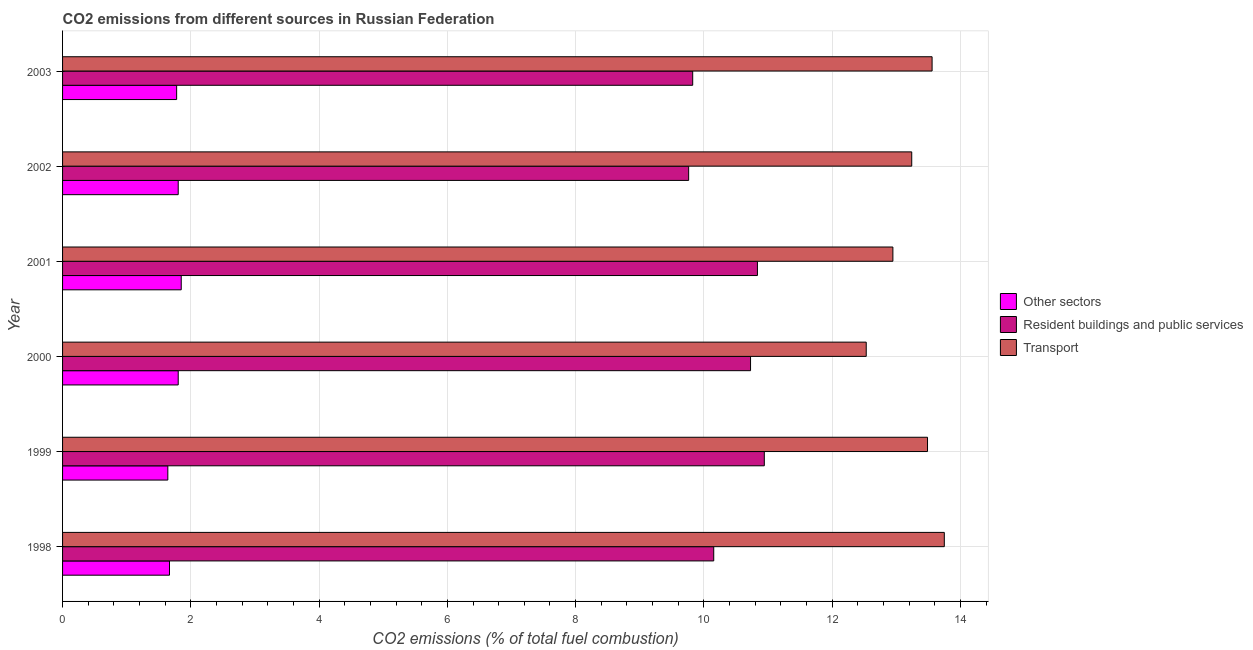How many different coloured bars are there?
Keep it short and to the point. 3. How many bars are there on the 3rd tick from the top?
Ensure brevity in your answer.  3. What is the label of the 3rd group of bars from the top?
Make the answer very short. 2001. What is the percentage of co2 emissions from resident buildings and public services in 1998?
Ensure brevity in your answer.  10.15. Across all years, what is the maximum percentage of co2 emissions from transport?
Ensure brevity in your answer.  13.75. Across all years, what is the minimum percentage of co2 emissions from transport?
Give a very brief answer. 12.53. In which year was the percentage of co2 emissions from other sectors maximum?
Keep it short and to the point. 2001. In which year was the percentage of co2 emissions from resident buildings and public services minimum?
Keep it short and to the point. 2002. What is the total percentage of co2 emissions from other sectors in the graph?
Offer a terse response. 10.54. What is the difference between the percentage of co2 emissions from other sectors in 2000 and that in 2002?
Your answer should be compact. -0. What is the difference between the percentage of co2 emissions from other sectors in 2000 and the percentage of co2 emissions from transport in 2001?
Offer a terse response. -11.14. What is the average percentage of co2 emissions from resident buildings and public services per year?
Offer a terse response. 10.37. In the year 2002, what is the difference between the percentage of co2 emissions from resident buildings and public services and percentage of co2 emissions from other sectors?
Keep it short and to the point. 7.96. What is the ratio of the percentage of co2 emissions from transport in 1998 to that in 2001?
Keep it short and to the point. 1.06. Is the difference between the percentage of co2 emissions from transport in 1998 and 2003 greater than the difference between the percentage of co2 emissions from other sectors in 1998 and 2003?
Provide a short and direct response. Yes. What is the difference between the highest and the second highest percentage of co2 emissions from resident buildings and public services?
Keep it short and to the point. 0.11. What is the difference between the highest and the lowest percentage of co2 emissions from other sectors?
Provide a succinct answer. 0.21. What does the 2nd bar from the top in 2001 represents?
Your response must be concise. Resident buildings and public services. What does the 3rd bar from the bottom in 1998 represents?
Make the answer very short. Transport. Is it the case that in every year, the sum of the percentage of co2 emissions from other sectors and percentage of co2 emissions from resident buildings and public services is greater than the percentage of co2 emissions from transport?
Provide a succinct answer. No. How many bars are there?
Provide a succinct answer. 18. How many years are there in the graph?
Provide a short and direct response. 6. What is the difference between two consecutive major ticks on the X-axis?
Keep it short and to the point. 2. Does the graph contain any zero values?
Offer a terse response. No. Does the graph contain grids?
Give a very brief answer. Yes. How many legend labels are there?
Provide a short and direct response. 3. How are the legend labels stacked?
Offer a very short reply. Vertical. What is the title of the graph?
Keep it short and to the point. CO2 emissions from different sources in Russian Federation. Does "Ages 50+" appear as one of the legend labels in the graph?
Provide a succinct answer. No. What is the label or title of the X-axis?
Your answer should be very brief. CO2 emissions (% of total fuel combustion). What is the CO2 emissions (% of total fuel combustion) in Other sectors in 1998?
Your answer should be compact. 1.67. What is the CO2 emissions (% of total fuel combustion) in Resident buildings and public services in 1998?
Your answer should be compact. 10.15. What is the CO2 emissions (% of total fuel combustion) in Transport in 1998?
Provide a succinct answer. 13.75. What is the CO2 emissions (% of total fuel combustion) in Other sectors in 1999?
Ensure brevity in your answer.  1.64. What is the CO2 emissions (% of total fuel combustion) in Resident buildings and public services in 1999?
Keep it short and to the point. 10.94. What is the CO2 emissions (% of total fuel combustion) in Transport in 1999?
Offer a very short reply. 13.49. What is the CO2 emissions (% of total fuel combustion) in Other sectors in 2000?
Give a very brief answer. 1.8. What is the CO2 emissions (% of total fuel combustion) of Resident buildings and public services in 2000?
Your answer should be very brief. 10.73. What is the CO2 emissions (% of total fuel combustion) of Transport in 2000?
Ensure brevity in your answer.  12.53. What is the CO2 emissions (% of total fuel combustion) in Other sectors in 2001?
Give a very brief answer. 1.85. What is the CO2 emissions (% of total fuel combustion) in Resident buildings and public services in 2001?
Keep it short and to the point. 10.84. What is the CO2 emissions (% of total fuel combustion) in Transport in 2001?
Keep it short and to the point. 12.95. What is the CO2 emissions (% of total fuel combustion) of Other sectors in 2002?
Your answer should be compact. 1.8. What is the CO2 emissions (% of total fuel combustion) in Resident buildings and public services in 2002?
Your answer should be compact. 9.76. What is the CO2 emissions (% of total fuel combustion) of Transport in 2002?
Make the answer very short. 13.24. What is the CO2 emissions (% of total fuel combustion) of Other sectors in 2003?
Provide a short and direct response. 1.78. What is the CO2 emissions (% of total fuel combustion) of Resident buildings and public services in 2003?
Provide a succinct answer. 9.83. What is the CO2 emissions (% of total fuel combustion) in Transport in 2003?
Your response must be concise. 13.56. Across all years, what is the maximum CO2 emissions (% of total fuel combustion) of Other sectors?
Keep it short and to the point. 1.85. Across all years, what is the maximum CO2 emissions (% of total fuel combustion) in Resident buildings and public services?
Keep it short and to the point. 10.94. Across all years, what is the maximum CO2 emissions (% of total fuel combustion) in Transport?
Provide a succinct answer. 13.75. Across all years, what is the minimum CO2 emissions (% of total fuel combustion) in Other sectors?
Provide a short and direct response. 1.64. Across all years, what is the minimum CO2 emissions (% of total fuel combustion) in Resident buildings and public services?
Ensure brevity in your answer.  9.76. Across all years, what is the minimum CO2 emissions (% of total fuel combustion) of Transport?
Give a very brief answer. 12.53. What is the total CO2 emissions (% of total fuel combustion) of Other sectors in the graph?
Your answer should be compact. 10.54. What is the total CO2 emissions (% of total fuel combustion) of Resident buildings and public services in the graph?
Make the answer very short. 62.25. What is the total CO2 emissions (% of total fuel combustion) of Transport in the graph?
Your response must be concise. 79.51. What is the difference between the CO2 emissions (% of total fuel combustion) of Other sectors in 1998 and that in 1999?
Your answer should be very brief. 0.03. What is the difference between the CO2 emissions (% of total fuel combustion) in Resident buildings and public services in 1998 and that in 1999?
Provide a succinct answer. -0.79. What is the difference between the CO2 emissions (% of total fuel combustion) of Transport in 1998 and that in 1999?
Provide a short and direct response. 0.26. What is the difference between the CO2 emissions (% of total fuel combustion) of Other sectors in 1998 and that in 2000?
Give a very brief answer. -0.14. What is the difference between the CO2 emissions (% of total fuel combustion) of Resident buildings and public services in 1998 and that in 2000?
Provide a succinct answer. -0.57. What is the difference between the CO2 emissions (% of total fuel combustion) of Transport in 1998 and that in 2000?
Your answer should be very brief. 1.22. What is the difference between the CO2 emissions (% of total fuel combustion) in Other sectors in 1998 and that in 2001?
Your response must be concise. -0.18. What is the difference between the CO2 emissions (% of total fuel combustion) in Resident buildings and public services in 1998 and that in 2001?
Provide a succinct answer. -0.68. What is the difference between the CO2 emissions (% of total fuel combustion) in Transport in 1998 and that in 2001?
Provide a short and direct response. 0.8. What is the difference between the CO2 emissions (% of total fuel combustion) of Other sectors in 1998 and that in 2002?
Keep it short and to the point. -0.14. What is the difference between the CO2 emissions (% of total fuel combustion) of Resident buildings and public services in 1998 and that in 2002?
Keep it short and to the point. 0.39. What is the difference between the CO2 emissions (% of total fuel combustion) of Transport in 1998 and that in 2002?
Ensure brevity in your answer.  0.51. What is the difference between the CO2 emissions (% of total fuel combustion) in Other sectors in 1998 and that in 2003?
Give a very brief answer. -0.11. What is the difference between the CO2 emissions (% of total fuel combustion) of Resident buildings and public services in 1998 and that in 2003?
Offer a terse response. 0.33. What is the difference between the CO2 emissions (% of total fuel combustion) in Transport in 1998 and that in 2003?
Provide a succinct answer. 0.19. What is the difference between the CO2 emissions (% of total fuel combustion) of Other sectors in 1999 and that in 2000?
Keep it short and to the point. -0.16. What is the difference between the CO2 emissions (% of total fuel combustion) of Resident buildings and public services in 1999 and that in 2000?
Keep it short and to the point. 0.21. What is the difference between the CO2 emissions (% of total fuel combustion) of Transport in 1999 and that in 2000?
Provide a succinct answer. 0.96. What is the difference between the CO2 emissions (% of total fuel combustion) of Other sectors in 1999 and that in 2001?
Provide a succinct answer. -0.21. What is the difference between the CO2 emissions (% of total fuel combustion) of Resident buildings and public services in 1999 and that in 2001?
Make the answer very short. 0.11. What is the difference between the CO2 emissions (% of total fuel combustion) in Transport in 1999 and that in 2001?
Provide a short and direct response. 0.54. What is the difference between the CO2 emissions (% of total fuel combustion) of Other sectors in 1999 and that in 2002?
Give a very brief answer. -0.16. What is the difference between the CO2 emissions (% of total fuel combustion) in Resident buildings and public services in 1999 and that in 2002?
Your response must be concise. 1.18. What is the difference between the CO2 emissions (% of total fuel combustion) of Transport in 1999 and that in 2002?
Your answer should be compact. 0.25. What is the difference between the CO2 emissions (% of total fuel combustion) of Other sectors in 1999 and that in 2003?
Your answer should be very brief. -0.14. What is the difference between the CO2 emissions (% of total fuel combustion) of Resident buildings and public services in 1999 and that in 2003?
Ensure brevity in your answer.  1.12. What is the difference between the CO2 emissions (% of total fuel combustion) in Transport in 1999 and that in 2003?
Provide a short and direct response. -0.07. What is the difference between the CO2 emissions (% of total fuel combustion) of Other sectors in 2000 and that in 2001?
Give a very brief answer. -0.05. What is the difference between the CO2 emissions (% of total fuel combustion) in Resident buildings and public services in 2000 and that in 2001?
Keep it short and to the point. -0.11. What is the difference between the CO2 emissions (% of total fuel combustion) in Transport in 2000 and that in 2001?
Provide a succinct answer. -0.42. What is the difference between the CO2 emissions (% of total fuel combustion) in Other sectors in 2000 and that in 2002?
Offer a terse response. -0. What is the difference between the CO2 emissions (% of total fuel combustion) in Resident buildings and public services in 2000 and that in 2002?
Provide a succinct answer. 0.96. What is the difference between the CO2 emissions (% of total fuel combustion) in Transport in 2000 and that in 2002?
Your response must be concise. -0.71. What is the difference between the CO2 emissions (% of total fuel combustion) of Other sectors in 2000 and that in 2003?
Give a very brief answer. 0.02. What is the difference between the CO2 emissions (% of total fuel combustion) of Resident buildings and public services in 2000 and that in 2003?
Offer a terse response. 0.9. What is the difference between the CO2 emissions (% of total fuel combustion) in Transport in 2000 and that in 2003?
Offer a very short reply. -1.03. What is the difference between the CO2 emissions (% of total fuel combustion) in Other sectors in 2001 and that in 2002?
Give a very brief answer. 0.05. What is the difference between the CO2 emissions (% of total fuel combustion) of Resident buildings and public services in 2001 and that in 2002?
Give a very brief answer. 1.07. What is the difference between the CO2 emissions (% of total fuel combustion) of Transport in 2001 and that in 2002?
Keep it short and to the point. -0.29. What is the difference between the CO2 emissions (% of total fuel combustion) in Other sectors in 2001 and that in 2003?
Provide a short and direct response. 0.07. What is the difference between the CO2 emissions (% of total fuel combustion) in Resident buildings and public services in 2001 and that in 2003?
Make the answer very short. 1.01. What is the difference between the CO2 emissions (% of total fuel combustion) of Transport in 2001 and that in 2003?
Keep it short and to the point. -0.61. What is the difference between the CO2 emissions (% of total fuel combustion) of Other sectors in 2002 and that in 2003?
Provide a succinct answer. 0.02. What is the difference between the CO2 emissions (% of total fuel combustion) of Resident buildings and public services in 2002 and that in 2003?
Ensure brevity in your answer.  -0.06. What is the difference between the CO2 emissions (% of total fuel combustion) of Transport in 2002 and that in 2003?
Provide a succinct answer. -0.32. What is the difference between the CO2 emissions (% of total fuel combustion) in Other sectors in 1998 and the CO2 emissions (% of total fuel combustion) in Resident buildings and public services in 1999?
Provide a short and direct response. -9.27. What is the difference between the CO2 emissions (% of total fuel combustion) of Other sectors in 1998 and the CO2 emissions (% of total fuel combustion) of Transport in 1999?
Your response must be concise. -11.82. What is the difference between the CO2 emissions (% of total fuel combustion) in Resident buildings and public services in 1998 and the CO2 emissions (% of total fuel combustion) in Transport in 1999?
Your answer should be very brief. -3.33. What is the difference between the CO2 emissions (% of total fuel combustion) of Other sectors in 1998 and the CO2 emissions (% of total fuel combustion) of Resident buildings and public services in 2000?
Provide a short and direct response. -9.06. What is the difference between the CO2 emissions (% of total fuel combustion) of Other sectors in 1998 and the CO2 emissions (% of total fuel combustion) of Transport in 2000?
Your response must be concise. -10.86. What is the difference between the CO2 emissions (% of total fuel combustion) in Resident buildings and public services in 1998 and the CO2 emissions (% of total fuel combustion) in Transport in 2000?
Keep it short and to the point. -2.38. What is the difference between the CO2 emissions (% of total fuel combustion) in Other sectors in 1998 and the CO2 emissions (% of total fuel combustion) in Resident buildings and public services in 2001?
Your answer should be very brief. -9.17. What is the difference between the CO2 emissions (% of total fuel combustion) in Other sectors in 1998 and the CO2 emissions (% of total fuel combustion) in Transport in 2001?
Offer a very short reply. -11.28. What is the difference between the CO2 emissions (% of total fuel combustion) of Resident buildings and public services in 1998 and the CO2 emissions (% of total fuel combustion) of Transport in 2001?
Offer a very short reply. -2.79. What is the difference between the CO2 emissions (% of total fuel combustion) in Other sectors in 1998 and the CO2 emissions (% of total fuel combustion) in Resident buildings and public services in 2002?
Provide a short and direct response. -8.1. What is the difference between the CO2 emissions (% of total fuel combustion) in Other sectors in 1998 and the CO2 emissions (% of total fuel combustion) in Transport in 2002?
Provide a succinct answer. -11.57. What is the difference between the CO2 emissions (% of total fuel combustion) of Resident buildings and public services in 1998 and the CO2 emissions (% of total fuel combustion) of Transport in 2002?
Provide a short and direct response. -3.09. What is the difference between the CO2 emissions (% of total fuel combustion) in Other sectors in 1998 and the CO2 emissions (% of total fuel combustion) in Resident buildings and public services in 2003?
Give a very brief answer. -8.16. What is the difference between the CO2 emissions (% of total fuel combustion) of Other sectors in 1998 and the CO2 emissions (% of total fuel combustion) of Transport in 2003?
Give a very brief answer. -11.89. What is the difference between the CO2 emissions (% of total fuel combustion) in Resident buildings and public services in 1998 and the CO2 emissions (% of total fuel combustion) in Transport in 2003?
Make the answer very short. -3.4. What is the difference between the CO2 emissions (% of total fuel combustion) in Other sectors in 1999 and the CO2 emissions (% of total fuel combustion) in Resident buildings and public services in 2000?
Offer a terse response. -9.09. What is the difference between the CO2 emissions (% of total fuel combustion) in Other sectors in 1999 and the CO2 emissions (% of total fuel combustion) in Transport in 2000?
Your answer should be compact. -10.89. What is the difference between the CO2 emissions (% of total fuel combustion) in Resident buildings and public services in 1999 and the CO2 emissions (% of total fuel combustion) in Transport in 2000?
Your answer should be very brief. -1.59. What is the difference between the CO2 emissions (% of total fuel combustion) of Other sectors in 1999 and the CO2 emissions (% of total fuel combustion) of Resident buildings and public services in 2001?
Your response must be concise. -9.19. What is the difference between the CO2 emissions (% of total fuel combustion) of Other sectors in 1999 and the CO2 emissions (% of total fuel combustion) of Transport in 2001?
Provide a succinct answer. -11.31. What is the difference between the CO2 emissions (% of total fuel combustion) in Resident buildings and public services in 1999 and the CO2 emissions (% of total fuel combustion) in Transport in 2001?
Offer a very short reply. -2. What is the difference between the CO2 emissions (% of total fuel combustion) of Other sectors in 1999 and the CO2 emissions (% of total fuel combustion) of Resident buildings and public services in 2002?
Give a very brief answer. -8.12. What is the difference between the CO2 emissions (% of total fuel combustion) of Other sectors in 1999 and the CO2 emissions (% of total fuel combustion) of Transport in 2002?
Offer a very short reply. -11.6. What is the difference between the CO2 emissions (% of total fuel combustion) in Resident buildings and public services in 1999 and the CO2 emissions (% of total fuel combustion) in Transport in 2002?
Ensure brevity in your answer.  -2.3. What is the difference between the CO2 emissions (% of total fuel combustion) in Other sectors in 1999 and the CO2 emissions (% of total fuel combustion) in Resident buildings and public services in 2003?
Keep it short and to the point. -8.18. What is the difference between the CO2 emissions (% of total fuel combustion) of Other sectors in 1999 and the CO2 emissions (% of total fuel combustion) of Transport in 2003?
Ensure brevity in your answer.  -11.92. What is the difference between the CO2 emissions (% of total fuel combustion) in Resident buildings and public services in 1999 and the CO2 emissions (% of total fuel combustion) in Transport in 2003?
Make the answer very short. -2.62. What is the difference between the CO2 emissions (% of total fuel combustion) in Other sectors in 2000 and the CO2 emissions (% of total fuel combustion) in Resident buildings and public services in 2001?
Give a very brief answer. -9.03. What is the difference between the CO2 emissions (% of total fuel combustion) of Other sectors in 2000 and the CO2 emissions (% of total fuel combustion) of Transport in 2001?
Provide a succinct answer. -11.14. What is the difference between the CO2 emissions (% of total fuel combustion) of Resident buildings and public services in 2000 and the CO2 emissions (% of total fuel combustion) of Transport in 2001?
Offer a very short reply. -2.22. What is the difference between the CO2 emissions (% of total fuel combustion) of Other sectors in 2000 and the CO2 emissions (% of total fuel combustion) of Resident buildings and public services in 2002?
Offer a very short reply. -7.96. What is the difference between the CO2 emissions (% of total fuel combustion) in Other sectors in 2000 and the CO2 emissions (% of total fuel combustion) in Transport in 2002?
Ensure brevity in your answer.  -11.44. What is the difference between the CO2 emissions (% of total fuel combustion) of Resident buildings and public services in 2000 and the CO2 emissions (% of total fuel combustion) of Transport in 2002?
Give a very brief answer. -2.51. What is the difference between the CO2 emissions (% of total fuel combustion) of Other sectors in 2000 and the CO2 emissions (% of total fuel combustion) of Resident buildings and public services in 2003?
Your response must be concise. -8.02. What is the difference between the CO2 emissions (% of total fuel combustion) in Other sectors in 2000 and the CO2 emissions (% of total fuel combustion) in Transport in 2003?
Your answer should be very brief. -11.76. What is the difference between the CO2 emissions (% of total fuel combustion) of Resident buildings and public services in 2000 and the CO2 emissions (% of total fuel combustion) of Transport in 2003?
Your answer should be compact. -2.83. What is the difference between the CO2 emissions (% of total fuel combustion) of Other sectors in 2001 and the CO2 emissions (% of total fuel combustion) of Resident buildings and public services in 2002?
Your answer should be compact. -7.91. What is the difference between the CO2 emissions (% of total fuel combustion) of Other sectors in 2001 and the CO2 emissions (% of total fuel combustion) of Transport in 2002?
Your response must be concise. -11.39. What is the difference between the CO2 emissions (% of total fuel combustion) of Resident buildings and public services in 2001 and the CO2 emissions (% of total fuel combustion) of Transport in 2002?
Your response must be concise. -2.41. What is the difference between the CO2 emissions (% of total fuel combustion) in Other sectors in 2001 and the CO2 emissions (% of total fuel combustion) in Resident buildings and public services in 2003?
Your answer should be very brief. -7.98. What is the difference between the CO2 emissions (% of total fuel combustion) of Other sectors in 2001 and the CO2 emissions (% of total fuel combustion) of Transport in 2003?
Provide a succinct answer. -11.71. What is the difference between the CO2 emissions (% of total fuel combustion) of Resident buildings and public services in 2001 and the CO2 emissions (% of total fuel combustion) of Transport in 2003?
Your response must be concise. -2.72. What is the difference between the CO2 emissions (% of total fuel combustion) of Other sectors in 2002 and the CO2 emissions (% of total fuel combustion) of Resident buildings and public services in 2003?
Make the answer very short. -8.02. What is the difference between the CO2 emissions (% of total fuel combustion) of Other sectors in 2002 and the CO2 emissions (% of total fuel combustion) of Transport in 2003?
Give a very brief answer. -11.76. What is the difference between the CO2 emissions (% of total fuel combustion) in Resident buildings and public services in 2002 and the CO2 emissions (% of total fuel combustion) in Transport in 2003?
Your response must be concise. -3.8. What is the average CO2 emissions (% of total fuel combustion) of Other sectors per year?
Make the answer very short. 1.76. What is the average CO2 emissions (% of total fuel combustion) in Resident buildings and public services per year?
Give a very brief answer. 10.37. What is the average CO2 emissions (% of total fuel combustion) in Transport per year?
Offer a terse response. 13.25. In the year 1998, what is the difference between the CO2 emissions (% of total fuel combustion) in Other sectors and CO2 emissions (% of total fuel combustion) in Resident buildings and public services?
Provide a short and direct response. -8.49. In the year 1998, what is the difference between the CO2 emissions (% of total fuel combustion) of Other sectors and CO2 emissions (% of total fuel combustion) of Transport?
Give a very brief answer. -12.08. In the year 1998, what is the difference between the CO2 emissions (% of total fuel combustion) in Resident buildings and public services and CO2 emissions (% of total fuel combustion) in Transport?
Give a very brief answer. -3.6. In the year 1999, what is the difference between the CO2 emissions (% of total fuel combustion) of Other sectors and CO2 emissions (% of total fuel combustion) of Resident buildings and public services?
Offer a terse response. -9.3. In the year 1999, what is the difference between the CO2 emissions (% of total fuel combustion) of Other sectors and CO2 emissions (% of total fuel combustion) of Transport?
Offer a very short reply. -11.85. In the year 1999, what is the difference between the CO2 emissions (% of total fuel combustion) in Resident buildings and public services and CO2 emissions (% of total fuel combustion) in Transport?
Provide a short and direct response. -2.54. In the year 2000, what is the difference between the CO2 emissions (% of total fuel combustion) in Other sectors and CO2 emissions (% of total fuel combustion) in Resident buildings and public services?
Ensure brevity in your answer.  -8.92. In the year 2000, what is the difference between the CO2 emissions (% of total fuel combustion) in Other sectors and CO2 emissions (% of total fuel combustion) in Transport?
Make the answer very short. -10.73. In the year 2000, what is the difference between the CO2 emissions (% of total fuel combustion) in Resident buildings and public services and CO2 emissions (% of total fuel combustion) in Transport?
Offer a terse response. -1.8. In the year 2001, what is the difference between the CO2 emissions (% of total fuel combustion) of Other sectors and CO2 emissions (% of total fuel combustion) of Resident buildings and public services?
Offer a very short reply. -8.98. In the year 2001, what is the difference between the CO2 emissions (% of total fuel combustion) in Other sectors and CO2 emissions (% of total fuel combustion) in Transport?
Keep it short and to the point. -11.1. In the year 2001, what is the difference between the CO2 emissions (% of total fuel combustion) in Resident buildings and public services and CO2 emissions (% of total fuel combustion) in Transport?
Ensure brevity in your answer.  -2.11. In the year 2002, what is the difference between the CO2 emissions (% of total fuel combustion) of Other sectors and CO2 emissions (% of total fuel combustion) of Resident buildings and public services?
Provide a short and direct response. -7.96. In the year 2002, what is the difference between the CO2 emissions (% of total fuel combustion) of Other sectors and CO2 emissions (% of total fuel combustion) of Transport?
Your answer should be compact. -11.44. In the year 2002, what is the difference between the CO2 emissions (% of total fuel combustion) of Resident buildings and public services and CO2 emissions (% of total fuel combustion) of Transport?
Keep it short and to the point. -3.48. In the year 2003, what is the difference between the CO2 emissions (% of total fuel combustion) of Other sectors and CO2 emissions (% of total fuel combustion) of Resident buildings and public services?
Your answer should be compact. -8.05. In the year 2003, what is the difference between the CO2 emissions (% of total fuel combustion) in Other sectors and CO2 emissions (% of total fuel combustion) in Transport?
Your answer should be very brief. -11.78. In the year 2003, what is the difference between the CO2 emissions (% of total fuel combustion) in Resident buildings and public services and CO2 emissions (% of total fuel combustion) in Transport?
Offer a very short reply. -3.73. What is the ratio of the CO2 emissions (% of total fuel combustion) in Other sectors in 1998 to that in 1999?
Offer a terse response. 1.02. What is the ratio of the CO2 emissions (% of total fuel combustion) of Resident buildings and public services in 1998 to that in 1999?
Keep it short and to the point. 0.93. What is the ratio of the CO2 emissions (% of total fuel combustion) of Transport in 1998 to that in 1999?
Provide a succinct answer. 1.02. What is the ratio of the CO2 emissions (% of total fuel combustion) of Other sectors in 1998 to that in 2000?
Ensure brevity in your answer.  0.92. What is the ratio of the CO2 emissions (% of total fuel combustion) in Resident buildings and public services in 1998 to that in 2000?
Provide a short and direct response. 0.95. What is the ratio of the CO2 emissions (% of total fuel combustion) in Transport in 1998 to that in 2000?
Your answer should be very brief. 1.1. What is the ratio of the CO2 emissions (% of total fuel combustion) of Other sectors in 1998 to that in 2001?
Your answer should be compact. 0.9. What is the ratio of the CO2 emissions (% of total fuel combustion) of Resident buildings and public services in 1998 to that in 2001?
Offer a very short reply. 0.94. What is the ratio of the CO2 emissions (% of total fuel combustion) of Transport in 1998 to that in 2001?
Provide a succinct answer. 1.06. What is the ratio of the CO2 emissions (% of total fuel combustion) of Other sectors in 1998 to that in 2002?
Offer a terse response. 0.92. What is the ratio of the CO2 emissions (% of total fuel combustion) in Resident buildings and public services in 1998 to that in 2002?
Keep it short and to the point. 1.04. What is the ratio of the CO2 emissions (% of total fuel combustion) of Transport in 1998 to that in 2002?
Keep it short and to the point. 1.04. What is the ratio of the CO2 emissions (% of total fuel combustion) in Other sectors in 1998 to that in 2003?
Provide a short and direct response. 0.94. What is the ratio of the CO2 emissions (% of total fuel combustion) in Resident buildings and public services in 1998 to that in 2003?
Make the answer very short. 1.03. What is the ratio of the CO2 emissions (% of total fuel combustion) in Transport in 1998 to that in 2003?
Your answer should be compact. 1.01. What is the ratio of the CO2 emissions (% of total fuel combustion) of Other sectors in 1999 to that in 2000?
Give a very brief answer. 0.91. What is the ratio of the CO2 emissions (% of total fuel combustion) of Resident buildings and public services in 1999 to that in 2000?
Offer a very short reply. 1.02. What is the ratio of the CO2 emissions (% of total fuel combustion) in Transport in 1999 to that in 2000?
Ensure brevity in your answer.  1.08. What is the ratio of the CO2 emissions (% of total fuel combustion) in Other sectors in 1999 to that in 2001?
Offer a terse response. 0.89. What is the ratio of the CO2 emissions (% of total fuel combustion) of Resident buildings and public services in 1999 to that in 2001?
Ensure brevity in your answer.  1.01. What is the ratio of the CO2 emissions (% of total fuel combustion) in Transport in 1999 to that in 2001?
Your response must be concise. 1.04. What is the ratio of the CO2 emissions (% of total fuel combustion) in Other sectors in 1999 to that in 2002?
Your response must be concise. 0.91. What is the ratio of the CO2 emissions (% of total fuel combustion) in Resident buildings and public services in 1999 to that in 2002?
Ensure brevity in your answer.  1.12. What is the ratio of the CO2 emissions (% of total fuel combustion) of Transport in 1999 to that in 2002?
Your answer should be compact. 1.02. What is the ratio of the CO2 emissions (% of total fuel combustion) in Other sectors in 1999 to that in 2003?
Your answer should be compact. 0.92. What is the ratio of the CO2 emissions (% of total fuel combustion) of Resident buildings and public services in 1999 to that in 2003?
Give a very brief answer. 1.11. What is the ratio of the CO2 emissions (% of total fuel combustion) in Transport in 1999 to that in 2003?
Keep it short and to the point. 0.99. What is the ratio of the CO2 emissions (% of total fuel combustion) in Other sectors in 2000 to that in 2001?
Make the answer very short. 0.97. What is the ratio of the CO2 emissions (% of total fuel combustion) of Resident buildings and public services in 2000 to that in 2001?
Offer a terse response. 0.99. What is the ratio of the CO2 emissions (% of total fuel combustion) in Transport in 2000 to that in 2001?
Make the answer very short. 0.97. What is the ratio of the CO2 emissions (% of total fuel combustion) in Other sectors in 2000 to that in 2002?
Your answer should be very brief. 1. What is the ratio of the CO2 emissions (% of total fuel combustion) in Resident buildings and public services in 2000 to that in 2002?
Your response must be concise. 1.1. What is the ratio of the CO2 emissions (% of total fuel combustion) in Transport in 2000 to that in 2002?
Ensure brevity in your answer.  0.95. What is the ratio of the CO2 emissions (% of total fuel combustion) of Other sectors in 2000 to that in 2003?
Your answer should be compact. 1.01. What is the ratio of the CO2 emissions (% of total fuel combustion) in Resident buildings and public services in 2000 to that in 2003?
Your answer should be very brief. 1.09. What is the ratio of the CO2 emissions (% of total fuel combustion) of Transport in 2000 to that in 2003?
Provide a short and direct response. 0.92. What is the ratio of the CO2 emissions (% of total fuel combustion) in Other sectors in 2001 to that in 2002?
Provide a succinct answer. 1.03. What is the ratio of the CO2 emissions (% of total fuel combustion) in Resident buildings and public services in 2001 to that in 2002?
Your answer should be compact. 1.11. What is the ratio of the CO2 emissions (% of total fuel combustion) in Transport in 2001 to that in 2002?
Provide a succinct answer. 0.98. What is the ratio of the CO2 emissions (% of total fuel combustion) in Other sectors in 2001 to that in 2003?
Make the answer very short. 1.04. What is the ratio of the CO2 emissions (% of total fuel combustion) in Resident buildings and public services in 2001 to that in 2003?
Offer a very short reply. 1.1. What is the ratio of the CO2 emissions (% of total fuel combustion) of Transport in 2001 to that in 2003?
Make the answer very short. 0.95. What is the ratio of the CO2 emissions (% of total fuel combustion) of Other sectors in 2002 to that in 2003?
Give a very brief answer. 1.01. What is the ratio of the CO2 emissions (% of total fuel combustion) in Transport in 2002 to that in 2003?
Your response must be concise. 0.98. What is the difference between the highest and the second highest CO2 emissions (% of total fuel combustion) in Other sectors?
Ensure brevity in your answer.  0.05. What is the difference between the highest and the second highest CO2 emissions (% of total fuel combustion) of Resident buildings and public services?
Your response must be concise. 0.11. What is the difference between the highest and the second highest CO2 emissions (% of total fuel combustion) in Transport?
Provide a succinct answer. 0.19. What is the difference between the highest and the lowest CO2 emissions (% of total fuel combustion) of Other sectors?
Offer a very short reply. 0.21. What is the difference between the highest and the lowest CO2 emissions (% of total fuel combustion) in Resident buildings and public services?
Your response must be concise. 1.18. What is the difference between the highest and the lowest CO2 emissions (% of total fuel combustion) in Transport?
Your answer should be very brief. 1.22. 